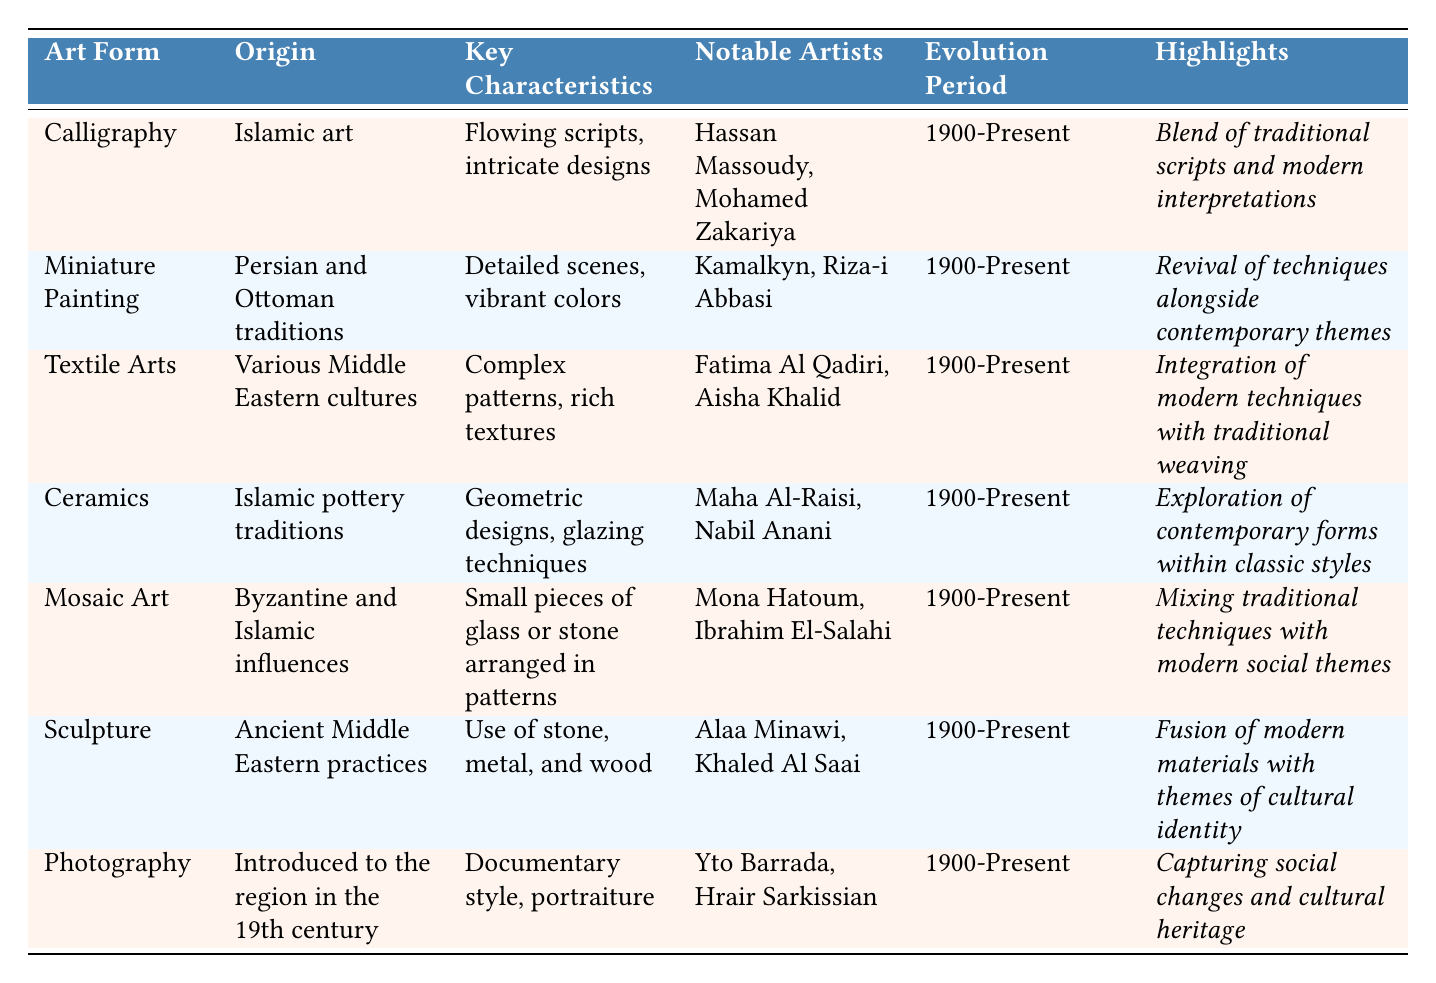What are the notable artists associated with Calligraphy? The table lists Hassan Massoudy and Mohamed Zakariya as the notable artists for Calligraphy.
Answer: Hassan Massoudy, Mohamed Zakariya Which art form has its origin in Islamic pottery traditions? The table indicates that Ceramics originate from Islamic pottery traditions.
Answer: Ceramics Is Miniature Painting characterized by detailed scenes and vibrant colors? Yes, the Key Characteristics for Miniature Painting in the table describe it as having detailed scenes and vibrant colors.
Answer: Yes What is the evolution period for Mosaic Art? The table shows that the evolution period for Mosaic Art is 1900-Present.
Answer: 1900-Present Which art form integrates modern techniques with traditional weaving? According to the table, Textile Arts integrate modern techniques with traditional weaving.
Answer: Textile Arts Are there any notable female artists listed in the table? Yes, Fatima Al Qadiri and Aisha Khalid are notable female artists associated with Textile Arts.
Answer: Yes How many art forms listed in the table originate from Islamic influences? The table lists three art forms with Islamic influences: Calligraphy, Ceramics, and Mosaic Art.
Answer: Three Which art form is associated with the use of stone, metal, and wood? Sculpture is the art form associated with the use of stone, metal, and wood as stated in the table.
Answer: Sculpture What are the key characteristics of Photography? The table details Photography as having a documentary style and portraiture as its key characteristics.
Answer: Documentary style, portraiture Which art form emphasizes the fusion of modern materials with cultural identity? The table indicates that Sculpture emphasizes the fusion of modern materials with themes of cultural identity.
Answer: Sculpture Which two art forms have origins related to Persian and Ottoman traditions? The table indicates that Miniature Painting and Textile Arts have origins related to Persian and Ottoman traditions.
Answer: Miniature Painting, Textile Arts What is the highlight of Ceramics in the context of its evolution? The highlight of Ceramics, according to the table, is the exploration of contemporary forms within classic styles.
Answer: Exploration of contemporary forms within classic styles How do the highlights of Calligraphy and Mosaic Art differ? Calligraphy emphasizes a blend of traditional scripts and modern interpretations, while Mosaic Art highlights mixing traditional techniques with modern social themes, showcasing different focal points in their evolution.
Answer: They differ in focus: Calligraphy emphasizes script and interpretation, Mosaic Art emphasizes social themes Which art form has the most notable artists mentioned? The table lists two notable artists for each art form; thus, each has equal mention, including Calligraphy, Miniature Painting, Textile Arts, Ceramics, Mosaic Art, Sculpture, and Photography.
Answer: All have two notable artists 